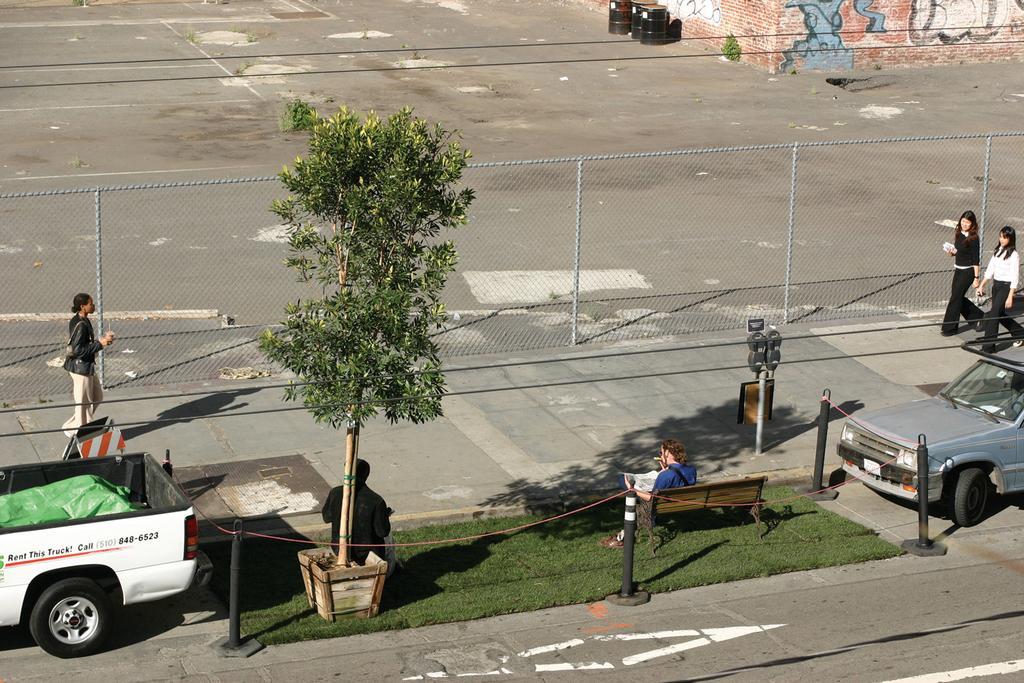Describe this image in one or two sentences. This picture shows three woman walking on the sidewalk and we see a man seated on the bench and reading a paper and we see other man seated under the tree and we see two cars parked on the side and we see metal fence which is the separating sidewalk and a road 